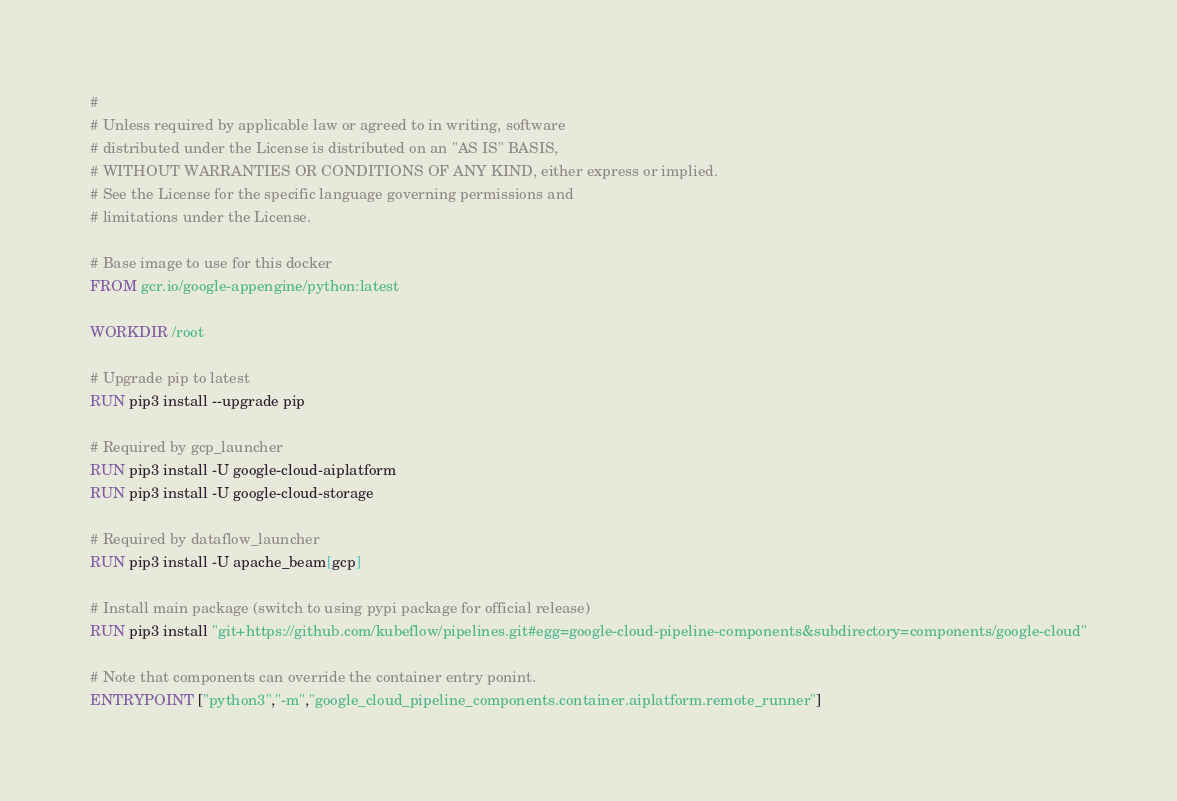<code> <loc_0><loc_0><loc_500><loc_500><_Dockerfile_>#
# Unless required by applicable law or agreed to in writing, software
# distributed under the License is distributed on an "AS IS" BASIS,
# WITHOUT WARRANTIES OR CONDITIONS OF ANY KIND, either express or implied.
# See the License for the specific language governing permissions and
# limitations under the License.

# Base image to use for this docker
FROM gcr.io/google-appengine/python:latest

WORKDIR /root

# Upgrade pip to latest
RUN pip3 install --upgrade pip

# Required by gcp_launcher
RUN pip3 install -U google-cloud-aiplatform
RUN pip3 install -U google-cloud-storage

# Required by dataflow_launcher
RUN pip3 install -U apache_beam[gcp]

# Install main package (switch to using pypi package for official release)
RUN pip3 install "git+https://github.com/kubeflow/pipelines.git#egg=google-cloud-pipeline-components&subdirectory=components/google-cloud"

# Note that components can override the container entry ponint.
ENTRYPOINT ["python3","-m","google_cloud_pipeline_components.container.aiplatform.remote_runner"]
</code> 